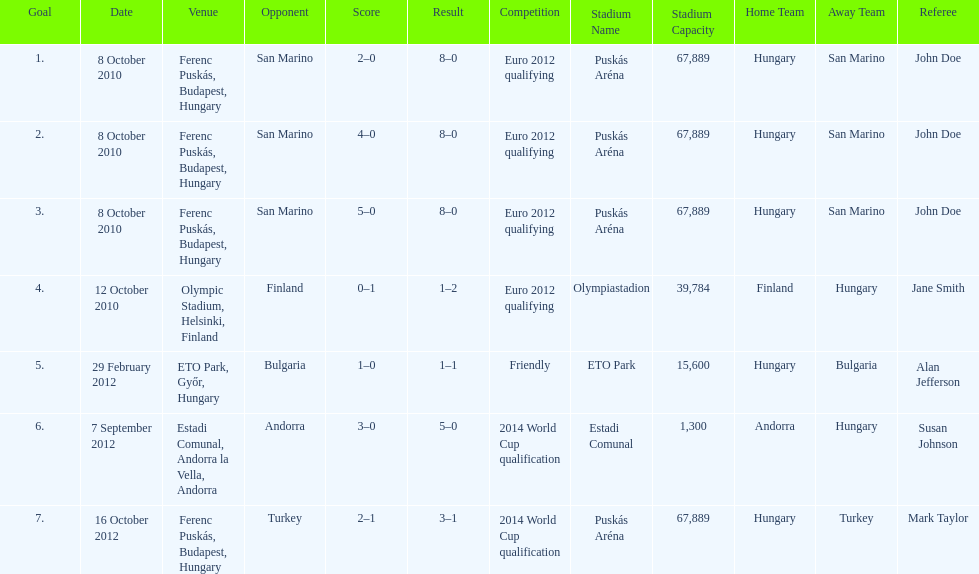In what year did ádám szalai make his next international goal after 2010? 2012. 